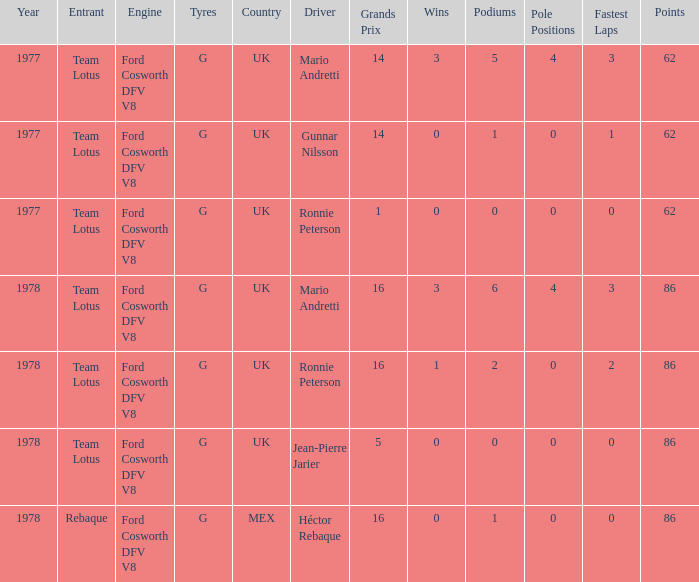What is the Focus that has a Year bigger than 1977? 86, 86, 86, 86. 